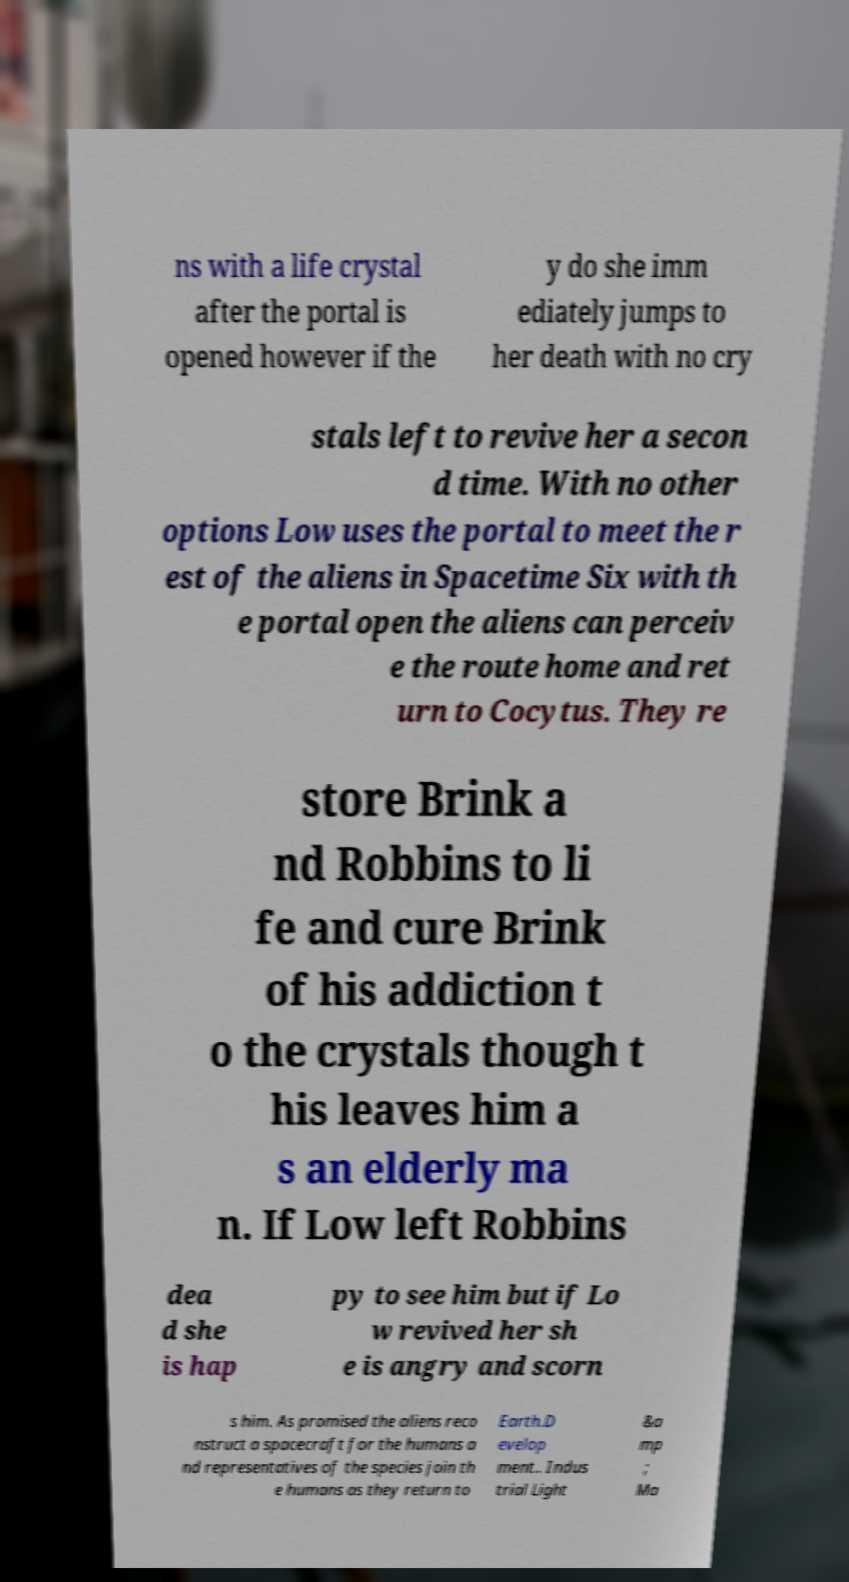Please identify and transcribe the text found in this image. ns with a life crystal after the portal is opened however if the y do she imm ediately jumps to her death with no cry stals left to revive her a secon d time. With no other options Low uses the portal to meet the r est of the aliens in Spacetime Six with th e portal open the aliens can perceiv e the route home and ret urn to Cocytus. They re store Brink a nd Robbins to li fe and cure Brink of his addiction t o the crystals though t his leaves him a s an elderly ma n. If Low left Robbins dea d she is hap py to see him but if Lo w revived her sh e is angry and scorn s him. As promised the aliens reco nstruct a spacecraft for the humans a nd representatives of the species join th e humans as they return to Earth.D evelop ment.. Indus trial Light &a mp ; Ma 